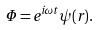<formula> <loc_0><loc_0><loc_500><loc_500>\Phi = e ^ { i \omega t } \psi ( r ) .</formula> 